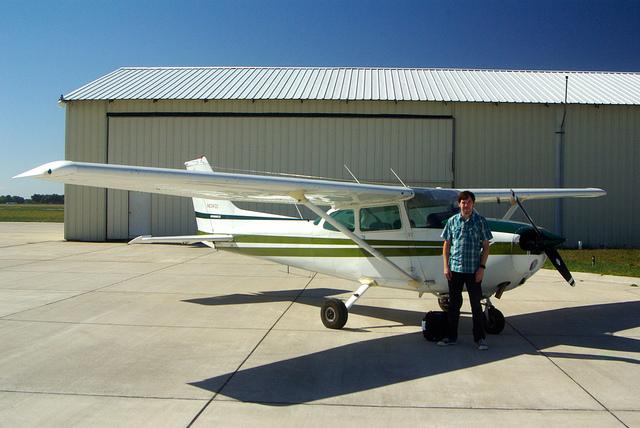Could this plane cross the Atlantic?
Answer briefly. No. What is the color of the strip on the plane?
Be succinct. Green. What is behind this person?
Give a very brief answer. Plane. 